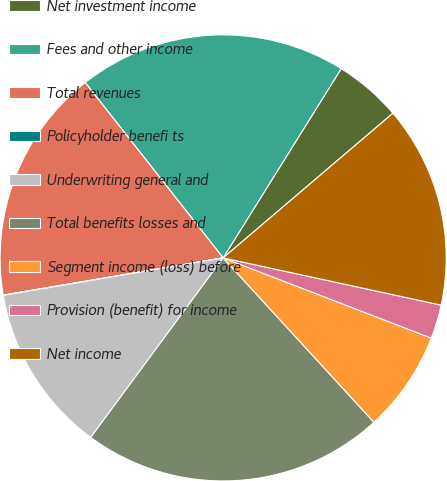Convert chart to OTSL. <chart><loc_0><loc_0><loc_500><loc_500><pie_chart><fcel>Net investment income<fcel>Fees and other income<fcel>Total revenues<fcel>Policyholder benefi ts<fcel>Underwriting general and<fcel>Total benefits losses and<fcel>Segment income (loss) before<fcel>Provision (benefit) for income<fcel>Net income<nl><fcel>4.89%<fcel>19.49%<fcel>17.06%<fcel>0.03%<fcel>12.19%<fcel>21.93%<fcel>7.33%<fcel>2.46%<fcel>14.63%<nl></chart> 